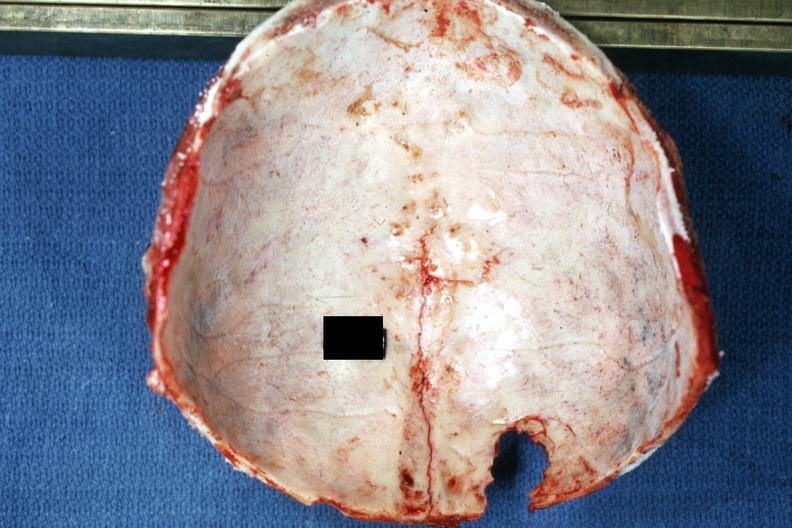what is present?
Answer the question using a single word or phrase. Bone 